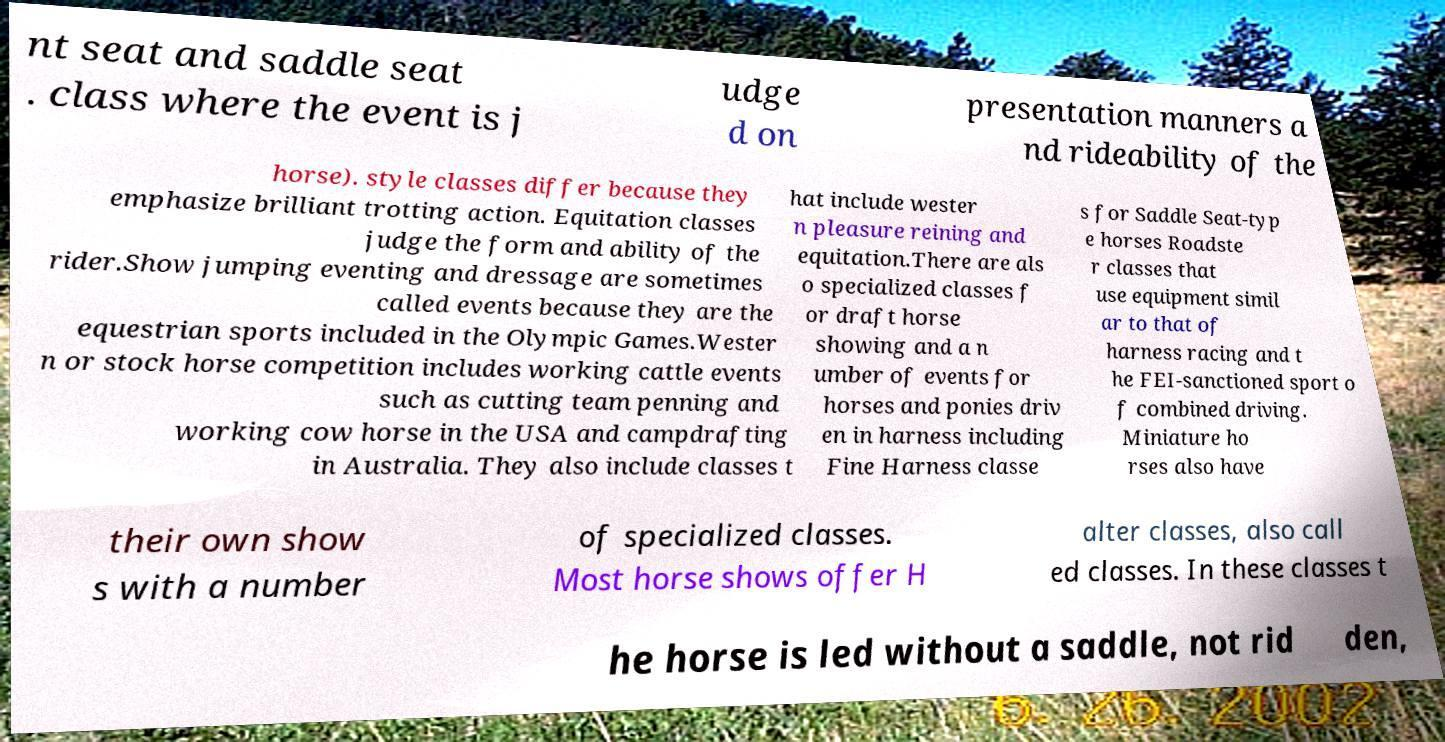Please identify and transcribe the text found in this image. nt seat and saddle seat . class where the event is j udge d on presentation manners a nd rideability of the horse). style classes differ because they emphasize brilliant trotting action. Equitation classes judge the form and ability of the rider.Show jumping eventing and dressage are sometimes called events because they are the equestrian sports included in the Olympic Games.Wester n or stock horse competition includes working cattle events such as cutting team penning and working cow horse in the USA and campdrafting in Australia. They also include classes t hat include wester n pleasure reining and equitation.There are als o specialized classes f or draft horse showing and a n umber of events for horses and ponies driv en in harness including Fine Harness classe s for Saddle Seat-typ e horses Roadste r classes that use equipment simil ar to that of harness racing and t he FEI-sanctioned sport o f combined driving. Miniature ho rses also have their own show s with a number of specialized classes. Most horse shows offer H alter classes, also call ed classes. In these classes t he horse is led without a saddle, not rid den, 